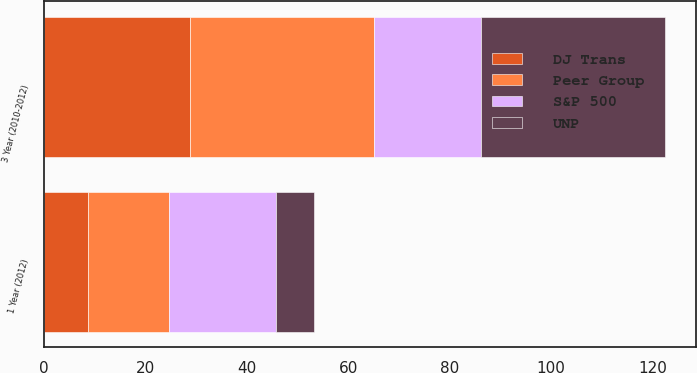<chart> <loc_0><loc_0><loc_500><loc_500><stacked_bar_chart><ecel><fcel>1 Year (2012)<fcel>3 Year (2010-2012)<nl><fcel>S&P 500<fcel>21.2<fcel>21.2<nl><fcel>DJ Trans<fcel>8.6<fcel>28.7<nl><fcel>UNP<fcel>7.5<fcel>36.3<nl><fcel>Peer Group<fcel>16<fcel>36.3<nl></chart> 